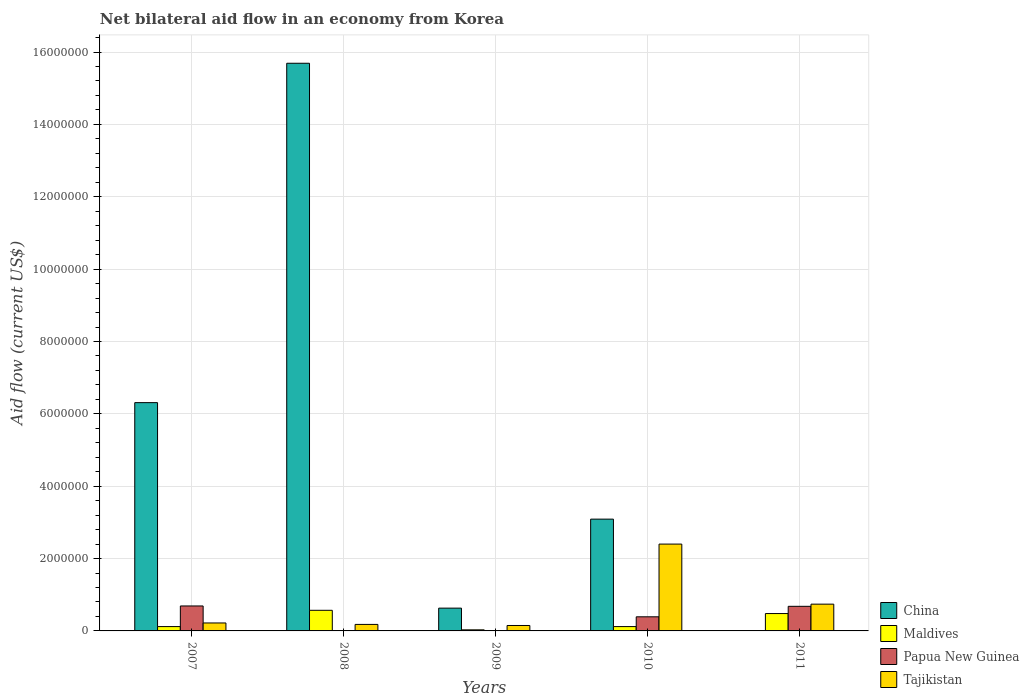How many groups of bars are there?
Make the answer very short. 5. What is the label of the 5th group of bars from the left?
Ensure brevity in your answer.  2011. In how many cases, is the number of bars for a given year not equal to the number of legend labels?
Offer a very short reply. 3. What is the net bilateral aid flow in Tajikistan in 2010?
Your response must be concise. 2.40e+06. Across all years, what is the maximum net bilateral aid flow in Tajikistan?
Your response must be concise. 2.40e+06. What is the total net bilateral aid flow in Papua New Guinea in the graph?
Make the answer very short. 1.76e+06. What is the difference between the net bilateral aid flow in Maldives in 2010 and that in 2011?
Your response must be concise. -3.60e+05. What is the difference between the net bilateral aid flow in China in 2007 and the net bilateral aid flow in Tajikistan in 2011?
Provide a succinct answer. 5.57e+06. What is the average net bilateral aid flow in Tajikistan per year?
Provide a succinct answer. 7.38e+05. In the year 2007, what is the difference between the net bilateral aid flow in Papua New Guinea and net bilateral aid flow in Maldives?
Keep it short and to the point. 5.70e+05. What is the ratio of the net bilateral aid flow in Maldives in 2008 to that in 2009?
Make the answer very short. 19. Is the difference between the net bilateral aid flow in Papua New Guinea in 2007 and 2010 greater than the difference between the net bilateral aid flow in Maldives in 2007 and 2010?
Your answer should be very brief. Yes. What is the difference between the highest and the second highest net bilateral aid flow in China?
Your answer should be compact. 9.38e+06. What is the difference between the highest and the lowest net bilateral aid flow in China?
Your answer should be very brief. 1.57e+07. Is the sum of the net bilateral aid flow in Maldives in 2007 and 2008 greater than the maximum net bilateral aid flow in China across all years?
Ensure brevity in your answer.  No. Are all the bars in the graph horizontal?
Make the answer very short. No. What is the difference between two consecutive major ticks on the Y-axis?
Ensure brevity in your answer.  2.00e+06. Where does the legend appear in the graph?
Ensure brevity in your answer.  Bottom right. What is the title of the graph?
Make the answer very short. Net bilateral aid flow in an economy from Korea. What is the label or title of the X-axis?
Ensure brevity in your answer.  Years. What is the Aid flow (current US$) in China in 2007?
Make the answer very short. 6.31e+06. What is the Aid flow (current US$) of Papua New Guinea in 2007?
Your answer should be compact. 6.90e+05. What is the Aid flow (current US$) in China in 2008?
Ensure brevity in your answer.  1.57e+07. What is the Aid flow (current US$) in Maldives in 2008?
Keep it short and to the point. 5.70e+05. What is the Aid flow (current US$) of Papua New Guinea in 2008?
Offer a terse response. 0. What is the Aid flow (current US$) of Tajikistan in 2008?
Offer a very short reply. 1.80e+05. What is the Aid flow (current US$) in China in 2009?
Make the answer very short. 6.30e+05. What is the Aid flow (current US$) in Papua New Guinea in 2009?
Keep it short and to the point. 0. What is the Aid flow (current US$) in China in 2010?
Offer a very short reply. 3.09e+06. What is the Aid flow (current US$) of Tajikistan in 2010?
Make the answer very short. 2.40e+06. What is the Aid flow (current US$) in China in 2011?
Give a very brief answer. 0. What is the Aid flow (current US$) in Maldives in 2011?
Your answer should be compact. 4.80e+05. What is the Aid flow (current US$) in Papua New Guinea in 2011?
Make the answer very short. 6.80e+05. What is the Aid flow (current US$) of Tajikistan in 2011?
Your answer should be compact. 7.40e+05. Across all years, what is the maximum Aid flow (current US$) of China?
Your response must be concise. 1.57e+07. Across all years, what is the maximum Aid flow (current US$) in Maldives?
Ensure brevity in your answer.  5.70e+05. Across all years, what is the maximum Aid flow (current US$) of Papua New Guinea?
Ensure brevity in your answer.  6.90e+05. Across all years, what is the maximum Aid flow (current US$) of Tajikistan?
Provide a short and direct response. 2.40e+06. Across all years, what is the minimum Aid flow (current US$) in Papua New Guinea?
Offer a very short reply. 0. What is the total Aid flow (current US$) of China in the graph?
Ensure brevity in your answer.  2.57e+07. What is the total Aid flow (current US$) of Maldives in the graph?
Provide a succinct answer. 1.32e+06. What is the total Aid flow (current US$) in Papua New Guinea in the graph?
Give a very brief answer. 1.76e+06. What is the total Aid flow (current US$) in Tajikistan in the graph?
Keep it short and to the point. 3.69e+06. What is the difference between the Aid flow (current US$) of China in 2007 and that in 2008?
Your response must be concise. -9.38e+06. What is the difference between the Aid flow (current US$) of Maldives in 2007 and that in 2008?
Ensure brevity in your answer.  -4.50e+05. What is the difference between the Aid flow (current US$) in Tajikistan in 2007 and that in 2008?
Your answer should be very brief. 4.00e+04. What is the difference between the Aid flow (current US$) in China in 2007 and that in 2009?
Provide a short and direct response. 5.68e+06. What is the difference between the Aid flow (current US$) in Maldives in 2007 and that in 2009?
Your response must be concise. 9.00e+04. What is the difference between the Aid flow (current US$) in Tajikistan in 2007 and that in 2009?
Give a very brief answer. 7.00e+04. What is the difference between the Aid flow (current US$) of China in 2007 and that in 2010?
Provide a short and direct response. 3.22e+06. What is the difference between the Aid flow (current US$) of Tajikistan in 2007 and that in 2010?
Offer a terse response. -2.18e+06. What is the difference between the Aid flow (current US$) of Maldives in 2007 and that in 2011?
Provide a short and direct response. -3.60e+05. What is the difference between the Aid flow (current US$) of Papua New Guinea in 2007 and that in 2011?
Keep it short and to the point. 10000. What is the difference between the Aid flow (current US$) in Tajikistan in 2007 and that in 2011?
Ensure brevity in your answer.  -5.20e+05. What is the difference between the Aid flow (current US$) of China in 2008 and that in 2009?
Offer a very short reply. 1.51e+07. What is the difference between the Aid flow (current US$) of Maldives in 2008 and that in 2009?
Provide a short and direct response. 5.40e+05. What is the difference between the Aid flow (current US$) in Tajikistan in 2008 and that in 2009?
Ensure brevity in your answer.  3.00e+04. What is the difference between the Aid flow (current US$) in China in 2008 and that in 2010?
Keep it short and to the point. 1.26e+07. What is the difference between the Aid flow (current US$) of Tajikistan in 2008 and that in 2010?
Offer a very short reply. -2.22e+06. What is the difference between the Aid flow (current US$) in Maldives in 2008 and that in 2011?
Give a very brief answer. 9.00e+04. What is the difference between the Aid flow (current US$) in Tajikistan in 2008 and that in 2011?
Give a very brief answer. -5.60e+05. What is the difference between the Aid flow (current US$) of China in 2009 and that in 2010?
Provide a succinct answer. -2.46e+06. What is the difference between the Aid flow (current US$) in Maldives in 2009 and that in 2010?
Keep it short and to the point. -9.00e+04. What is the difference between the Aid flow (current US$) of Tajikistan in 2009 and that in 2010?
Make the answer very short. -2.25e+06. What is the difference between the Aid flow (current US$) of Maldives in 2009 and that in 2011?
Offer a very short reply. -4.50e+05. What is the difference between the Aid flow (current US$) of Tajikistan in 2009 and that in 2011?
Offer a terse response. -5.90e+05. What is the difference between the Aid flow (current US$) of Maldives in 2010 and that in 2011?
Provide a succinct answer. -3.60e+05. What is the difference between the Aid flow (current US$) in Papua New Guinea in 2010 and that in 2011?
Ensure brevity in your answer.  -2.90e+05. What is the difference between the Aid flow (current US$) in Tajikistan in 2010 and that in 2011?
Offer a very short reply. 1.66e+06. What is the difference between the Aid flow (current US$) in China in 2007 and the Aid flow (current US$) in Maldives in 2008?
Make the answer very short. 5.74e+06. What is the difference between the Aid flow (current US$) of China in 2007 and the Aid flow (current US$) of Tajikistan in 2008?
Make the answer very short. 6.13e+06. What is the difference between the Aid flow (current US$) of Maldives in 2007 and the Aid flow (current US$) of Tajikistan in 2008?
Give a very brief answer. -6.00e+04. What is the difference between the Aid flow (current US$) in Papua New Guinea in 2007 and the Aid flow (current US$) in Tajikistan in 2008?
Keep it short and to the point. 5.10e+05. What is the difference between the Aid flow (current US$) in China in 2007 and the Aid flow (current US$) in Maldives in 2009?
Your answer should be compact. 6.28e+06. What is the difference between the Aid flow (current US$) of China in 2007 and the Aid flow (current US$) of Tajikistan in 2009?
Make the answer very short. 6.16e+06. What is the difference between the Aid flow (current US$) in Papua New Guinea in 2007 and the Aid flow (current US$) in Tajikistan in 2009?
Keep it short and to the point. 5.40e+05. What is the difference between the Aid flow (current US$) of China in 2007 and the Aid flow (current US$) of Maldives in 2010?
Ensure brevity in your answer.  6.19e+06. What is the difference between the Aid flow (current US$) in China in 2007 and the Aid flow (current US$) in Papua New Guinea in 2010?
Ensure brevity in your answer.  5.92e+06. What is the difference between the Aid flow (current US$) of China in 2007 and the Aid flow (current US$) of Tajikistan in 2010?
Offer a very short reply. 3.91e+06. What is the difference between the Aid flow (current US$) of Maldives in 2007 and the Aid flow (current US$) of Tajikistan in 2010?
Give a very brief answer. -2.28e+06. What is the difference between the Aid flow (current US$) of Papua New Guinea in 2007 and the Aid flow (current US$) of Tajikistan in 2010?
Offer a very short reply. -1.71e+06. What is the difference between the Aid flow (current US$) of China in 2007 and the Aid flow (current US$) of Maldives in 2011?
Your answer should be very brief. 5.83e+06. What is the difference between the Aid flow (current US$) in China in 2007 and the Aid flow (current US$) in Papua New Guinea in 2011?
Ensure brevity in your answer.  5.63e+06. What is the difference between the Aid flow (current US$) in China in 2007 and the Aid flow (current US$) in Tajikistan in 2011?
Your response must be concise. 5.57e+06. What is the difference between the Aid flow (current US$) in Maldives in 2007 and the Aid flow (current US$) in Papua New Guinea in 2011?
Ensure brevity in your answer.  -5.60e+05. What is the difference between the Aid flow (current US$) of Maldives in 2007 and the Aid flow (current US$) of Tajikistan in 2011?
Offer a very short reply. -6.20e+05. What is the difference between the Aid flow (current US$) of Papua New Guinea in 2007 and the Aid flow (current US$) of Tajikistan in 2011?
Provide a short and direct response. -5.00e+04. What is the difference between the Aid flow (current US$) in China in 2008 and the Aid flow (current US$) in Maldives in 2009?
Ensure brevity in your answer.  1.57e+07. What is the difference between the Aid flow (current US$) in China in 2008 and the Aid flow (current US$) in Tajikistan in 2009?
Ensure brevity in your answer.  1.55e+07. What is the difference between the Aid flow (current US$) in Maldives in 2008 and the Aid flow (current US$) in Tajikistan in 2009?
Your answer should be compact. 4.20e+05. What is the difference between the Aid flow (current US$) in China in 2008 and the Aid flow (current US$) in Maldives in 2010?
Give a very brief answer. 1.56e+07. What is the difference between the Aid flow (current US$) in China in 2008 and the Aid flow (current US$) in Papua New Guinea in 2010?
Your answer should be very brief. 1.53e+07. What is the difference between the Aid flow (current US$) of China in 2008 and the Aid flow (current US$) of Tajikistan in 2010?
Provide a succinct answer. 1.33e+07. What is the difference between the Aid flow (current US$) in Maldives in 2008 and the Aid flow (current US$) in Tajikistan in 2010?
Keep it short and to the point. -1.83e+06. What is the difference between the Aid flow (current US$) of China in 2008 and the Aid flow (current US$) of Maldives in 2011?
Your response must be concise. 1.52e+07. What is the difference between the Aid flow (current US$) in China in 2008 and the Aid flow (current US$) in Papua New Guinea in 2011?
Your response must be concise. 1.50e+07. What is the difference between the Aid flow (current US$) in China in 2008 and the Aid flow (current US$) in Tajikistan in 2011?
Keep it short and to the point. 1.50e+07. What is the difference between the Aid flow (current US$) in Maldives in 2008 and the Aid flow (current US$) in Tajikistan in 2011?
Provide a succinct answer. -1.70e+05. What is the difference between the Aid flow (current US$) in China in 2009 and the Aid flow (current US$) in Maldives in 2010?
Your response must be concise. 5.10e+05. What is the difference between the Aid flow (current US$) of China in 2009 and the Aid flow (current US$) of Papua New Guinea in 2010?
Offer a terse response. 2.40e+05. What is the difference between the Aid flow (current US$) of China in 2009 and the Aid flow (current US$) of Tajikistan in 2010?
Offer a very short reply. -1.77e+06. What is the difference between the Aid flow (current US$) of Maldives in 2009 and the Aid flow (current US$) of Papua New Guinea in 2010?
Keep it short and to the point. -3.60e+05. What is the difference between the Aid flow (current US$) of Maldives in 2009 and the Aid flow (current US$) of Tajikistan in 2010?
Keep it short and to the point. -2.37e+06. What is the difference between the Aid flow (current US$) in China in 2009 and the Aid flow (current US$) in Papua New Guinea in 2011?
Give a very brief answer. -5.00e+04. What is the difference between the Aid flow (current US$) in Maldives in 2009 and the Aid flow (current US$) in Papua New Guinea in 2011?
Your response must be concise. -6.50e+05. What is the difference between the Aid flow (current US$) of Maldives in 2009 and the Aid flow (current US$) of Tajikistan in 2011?
Your response must be concise. -7.10e+05. What is the difference between the Aid flow (current US$) of China in 2010 and the Aid flow (current US$) of Maldives in 2011?
Ensure brevity in your answer.  2.61e+06. What is the difference between the Aid flow (current US$) of China in 2010 and the Aid flow (current US$) of Papua New Guinea in 2011?
Give a very brief answer. 2.41e+06. What is the difference between the Aid flow (current US$) of China in 2010 and the Aid flow (current US$) of Tajikistan in 2011?
Your answer should be compact. 2.35e+06. What is the difference between the Aid flow (current US$) in Maldives in 2010 and the Aid flow (current US$) in Papua New Guinea in 2011?
Ensure brevity in your answer.  -5.60e+05. What is the difference between the Aid flow (current US$) in Maldives in 2010 and the Aid flow (current US$) in Tajikistan in 2011?
Make the answer very short. -6.20e+05. What is the difference between the Aid flow (current US$) of Papua New Guinea in 2010 and the Aid flow (current US$) of Tajikistan in 2011?
Keep it short and to the point. -3.50e+05. What is the average Aid flow (current US$) in China per year?
Offer a terse response. 5.14e+06. What is the average Aid flow (current US$) in Maldives per year?
Ensure brevity in your answer.  2.64e+05. What is the average Aid flow (current US$) of Papua New Guinea per year?
Provide a short and direct response. 3.52e+05. What is the average Aid flow (current US$) in Tajikistan per year?
Your answer should be very brief. 7.38e+05. In the year 2007, what is the difference between the Aid flow (current US$) of China and Aid flow (current US$) of Maldives?
Provide a succinct answer. 6.19e+06. In the year 2007, what is the difference between the Aid flow (current US$) in China and Aid flow (current US$) in Papua New Guinea?
Provide a succinct answer. 5.62e+06. In the year 2007, what is the difference between the Aid flow (current US$) of China and Aid flow (current US$) of Tajikistan?
Keep it short and to the point. 6.09e+06. In the year 2007, what is the difference between the Aid flow (current US$) in Maldives and Aid flow (current US$) in Papua New Guinea?
Your response must be concise. -5.70e+05. In the year 2007, what is the difference between the Aid flow (current US$) of Maldives and Aid flow (current US$) of Tajikistan?
Offer a very short reply. -1.00e+05. In the year 2008, what is the difference between the Aid flow (current US$) of China and Aid flow (current US$) of Maldives?
Offer a terse response. 1.51e+07. In the year 2008, what is the difference between the Aid flow (current US$) in China and Aid flow (current US$) in Tajikistan?
Your answer should be compact. 1.55e+07. In the year 2009, what is the difference between the Aid flow (current US$) in China and Aid flow (current US$) in Maldives?
Your response must be concise. 6.00e+05. In the year 2009, what is the difference between the Aid flow (current US$) in Maldives and Aid flow (current US$) in Tajikistan?
Make the answer very short. -1.20e+05. In the year 2010, what is the difference between the Aid flow (current US$) in China and Aid flow (current US$) in Maldives?
Give a very brief answer. 2.97e+06. In the year 2010, what is the difference between the Aid flow (current US$) of China and Aid flow (current US$) of Papua New Guinea?
Your answer should be very brief. 2.70e+06. In the year 2010, what is the difference between the Aid flow (current US$) in China and Aid flow (current US$) in Tajikistan?
Ensure brevity in your answer.  6.90e+05. In the year 2010, what is the difference between the Aid flow (current US$) in Maldives and Aid flow (current US$) in Papua New Guinea?
Your answer should be compact. -2.70e+05. In the year 2010, what is the difference between the Aid flow (current US$) in Maldives and Aid flow (current US$) in Tajikistan?
Offer a very short reply. -2.28e+06. In the year 2010, what is the difference between the Aid flow (current US$) of Papua New Guinea and Aid flow (current US$) of Tajikistan?
Your response must be concise. -2.01e+06. In the year 2011, what is the difference between the Aid flow (current US$) in Maldives and Aid flow (current US$) in Papua New Guinea?
Your answer should be very brief. -2.00e+05. In the year 2011, what is the difference between the Aid flow (current US$) in Maldives and Aid flow (current US$) in Tajikistan?
Your response must be concise. -2.60e+05. What is the ratio of the Aid flow (current US$) of China in 2007 to that in 2008?
Ensure brevity in your answer.  0.4. What is the ratio of the Aid flow (current US$) in Maldives in 2007 to that in 2008?
Offer a very short reply. 0.21. What is the ratio of the Aid flow (current US$) in Tajikistan in 2007 to that in 2008?
Your answer should be very brief. 1.22. What is the ratio of the Aid flow (current US$) in China in 2007 to that in 2009?
Give a very brief answer. 10.02. What is the ratio of the Aid flow (current US$) in Maldives in 2007 to that in 2009?
Provide a succinct answer. 4. What is the ratio of the Aid flow (current US$) of Tajikistan in 2007 to that in 2009?
Keep it short and to the point. 1.47. What is the ratio of the Aid flow (current US$) in China in 2007 to that in 2010?
Offer a terse response. 2.04. What is the ratio of the Aid flow (current US$) of Maldives in 2007 to that in 2010?
Provide a succinct answer. 1. What is the ratio of the Aid flow (current US$) of Papua New Guinea in 2007 to that in 2010?
Offer a very short reply. 1.77. What is the ratio of the Aid flow (current US$) of Tajikistan in 2007 to that in 2010?
Your answer should be very brief. 0.09. What is the ratio of the Aid flow (current US$) in Papua New Guinea in 2007 to that in 2011?
Provide a short and direct response. 1.01. What is the ratio of the Aid flow (current US$) of Tajikistan in 2007 to that in 2011?
Provide a succinct answer. 0.3. What is the ratio of the Aid flow (current US$) of China in 2008 to that in 2009?
Your response must be concise. 24.9. What is the ratio of the Aid flow (current US$) of Tajikistan in 2008 to that in 2009?
Provide a succinct answer. 1.2. What is the ratio of the Aid flow (current US$) of China in 2008 to that in 2010?
Offer a terse response. 5.08. What is the ratio of the Aid flow (current US$) in Maldives in 2008 to that in 2010?
Your answer should be very brief. 4.75. What is the ratio of the Aid flow (current US$) of Tajikistan in 2008 to that in 2010?
Provide a short and direct response. 0.07. What is the ratio of the Aid flow (current US$) of Maldives in 2008 to that in 2011?
Make the answer very short. 1.19. What is the ratio of the Aid flow (current US$) in Tajikistan in 2008 to that in 2011?
Your response must be concise. 0.24. What is the ratio of the Aid flow (current US$) of China in 2009 to that in 2010?
Give a very brief answer. 0.2. What is the ratio of the Aid flow (current US$) of Maldives in 2009 to that in 2010?
Provide a succinct answer. 0.25. What is the ratio of the Aid flow (current US$) of Tajikistan in 2009 to that in 2010?
Your answer should be very brief. 0.06. What is the ratio of the Aid flow (current US$) in Maldives in 2009 to that in 2011?
Offer a terse response. 0.06. What is the ratio of the Aid flow (current US$) in Tajikistan in 2009 to that in 2011?
Provide a short and direct response. 0.2. What is the ratio of the Aid flow (current US$) of Maldives in 2010 to that in 2011?
Provide a succinct answer. 0.25. What is the ratio of the Aid flow (current US$) of Papua New Guinea in 2010 to that in 2011?
Offer a terse response. 0.57. What is the ratio of the Aid flow (current US$) in Tajikistan in 2010 to that in 2011?
Provide a short and direct response. 3.24. What is the difference between the highest and the second highest Aid flow (current US$) in China?
Your answer should be very brief. 9.38e+06. What is the difference between the highest and the second highest Aid flow (current US$) in Papua New Guinea?
Provide a short and direct response. 10000. What is the difference between the highest and the second highest Aid flow (current US$) of Tajikistan?
Your response must be concise. 1.66e+06. What is the difference between the highest and the lowest Aid flow (current US$) of China?
Make the answer very short. 1.57e+07. What is the difference between the highest and the lowest Aid flow (current US$) of Maldives?
Offer a very short reply. 5.40e+05. What is the difference between the highest and the lowest Aid flow (current US$) of Papua New Guinea?
Your response must be concise. 6.90e+05. What is the difference between the highest and the lowest Aid flow (current US$) of Tajikistan?
Offer a very short reply. 2.25e+06. 